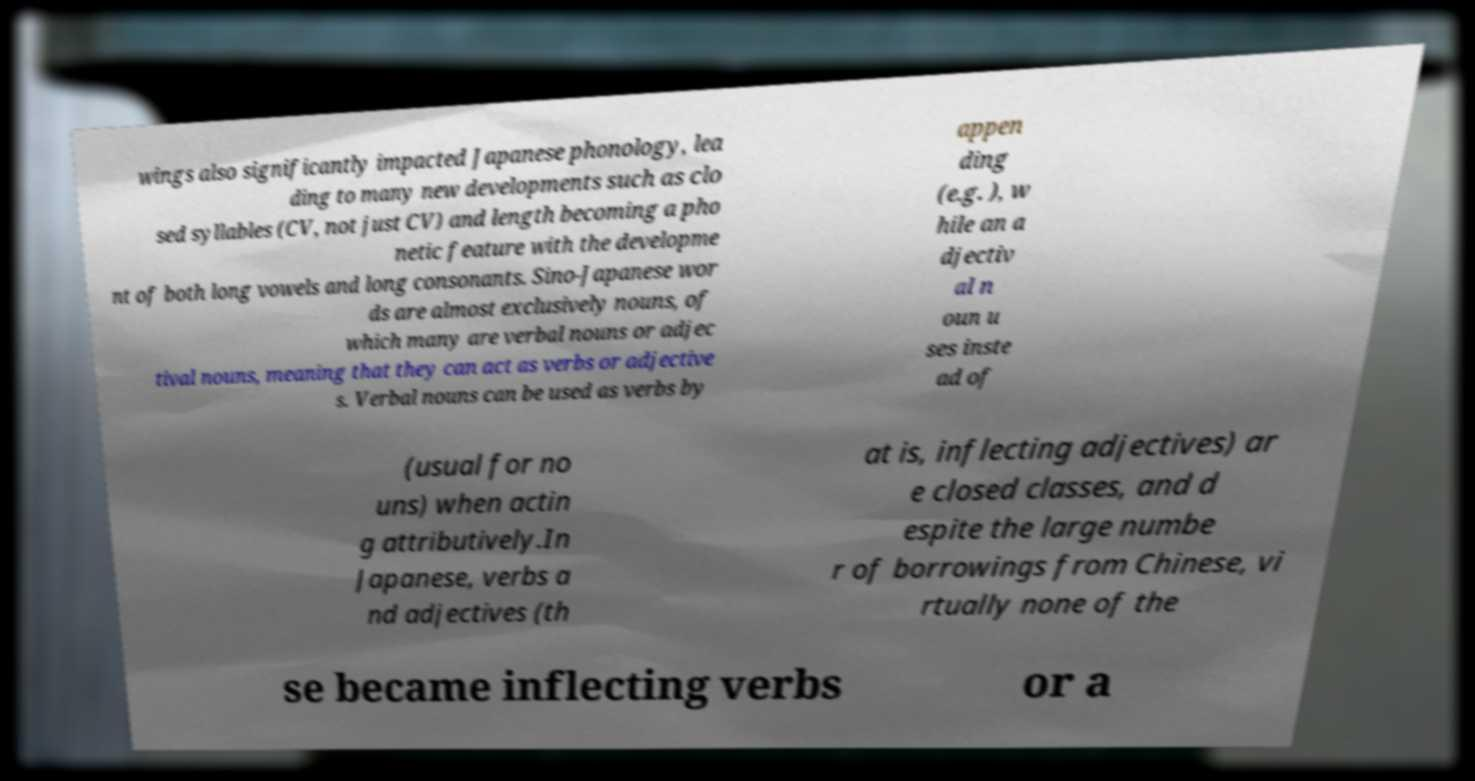For documentation purposes, I need the text within this image transcribed. Could you provide that? wings also significantly impacted Japanese phonology, lea ding to many new developments such as clo sed syllables (CV, not just CV) and length becoming a pho netic feature with the developme nt of both long vowels and long consonants. Sino-Japanese wor ds are almost exclusively nouns, of which many are verbal nouns or adjec tival nouns, meaning that they can act as verbs or adjective s. Verbal nouns can be used as verbs by appen ding (e.g. ), w hile an a djectiv al n oun u ses inste ad of (usual for no uns) when actin g attributively.In Japanese, verbs a nd adjectives (th at is, inflecting adjectives) ar e closed classes, and d espite the large numbe r of borrowings from Chinese, vi rtually none of the se became inflecting verbs or a 